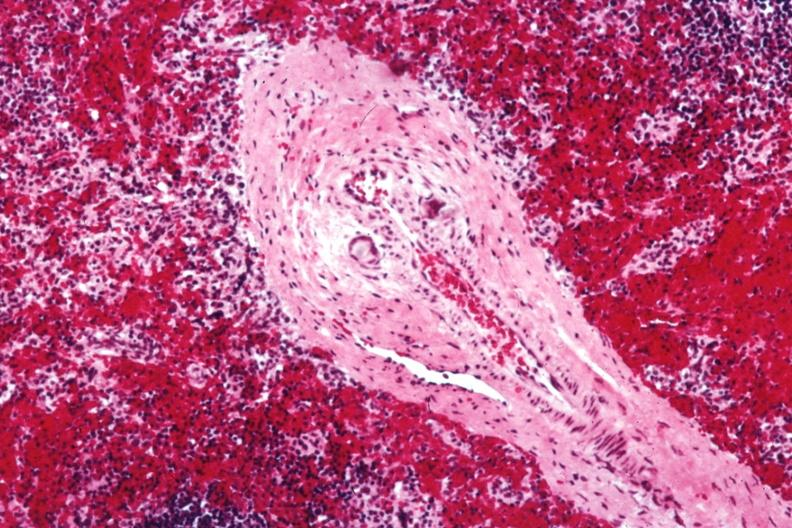does hematoma show med artery with giant cells in wall containing crystalline material postoperative cardiac surgery thought to be silicon?
Answer the question using a single word or phrase. No 